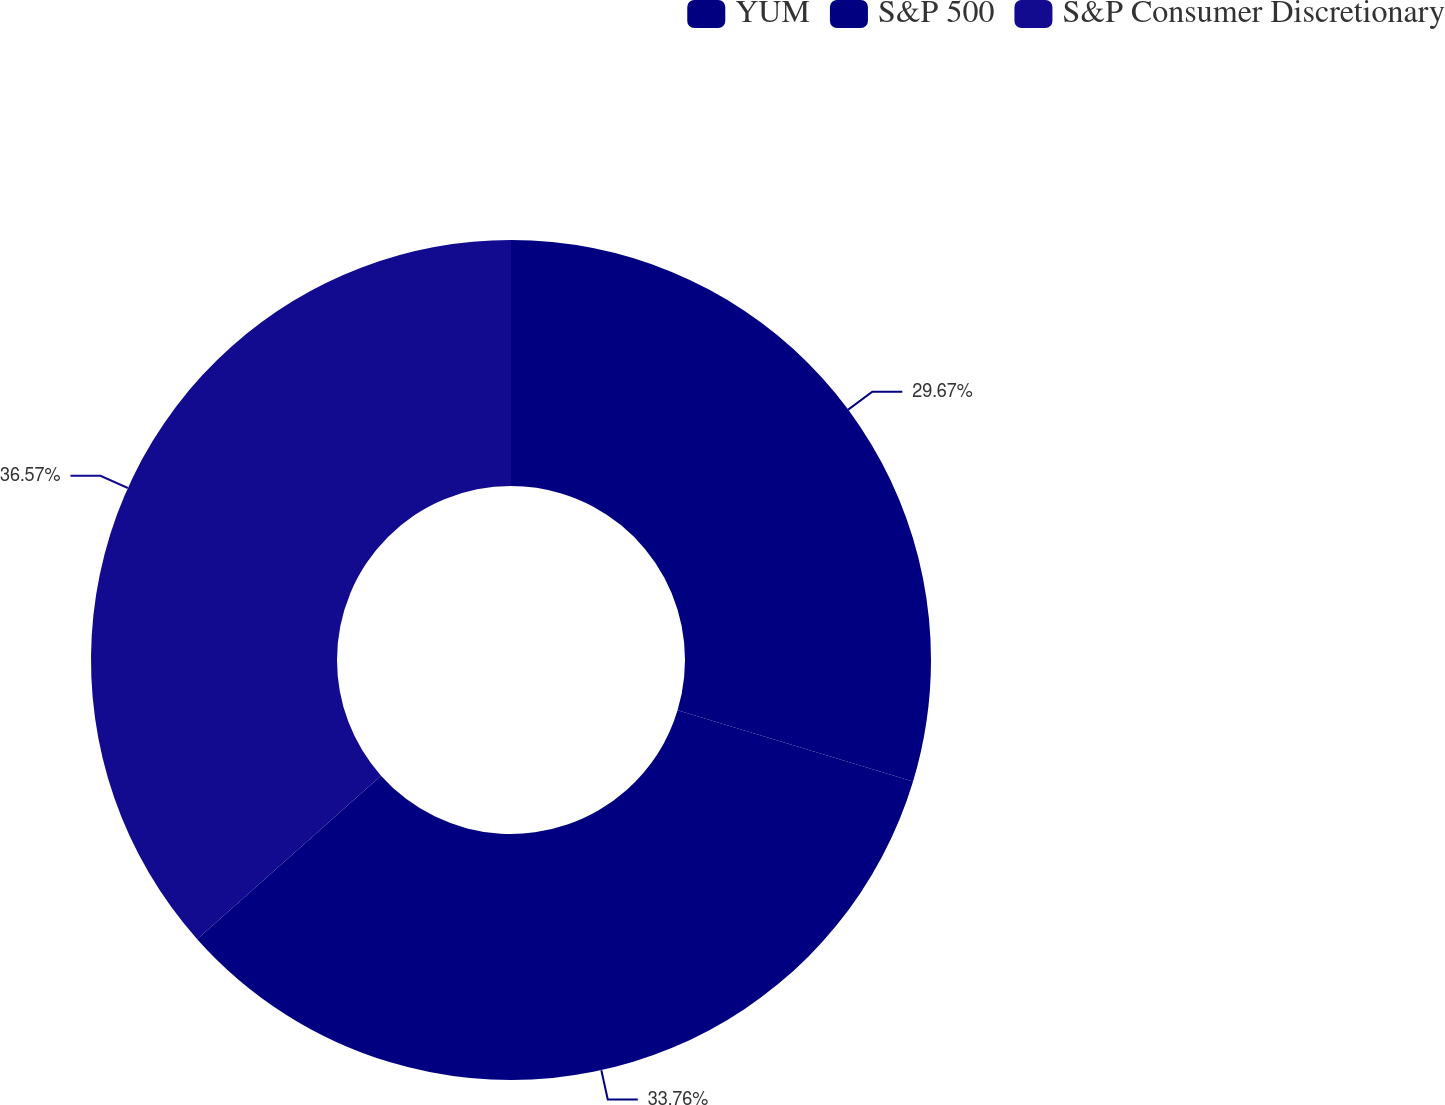<chart> <loc_0><loc_0><loc_500><loc_500><pie_chart><fcel>YUM<fcel>S&P 500<fcel>S&P Consumer Discretionary<nl><fcel>29.67%<fcel>33.76%<fcel>36.57%<nl></chart> 